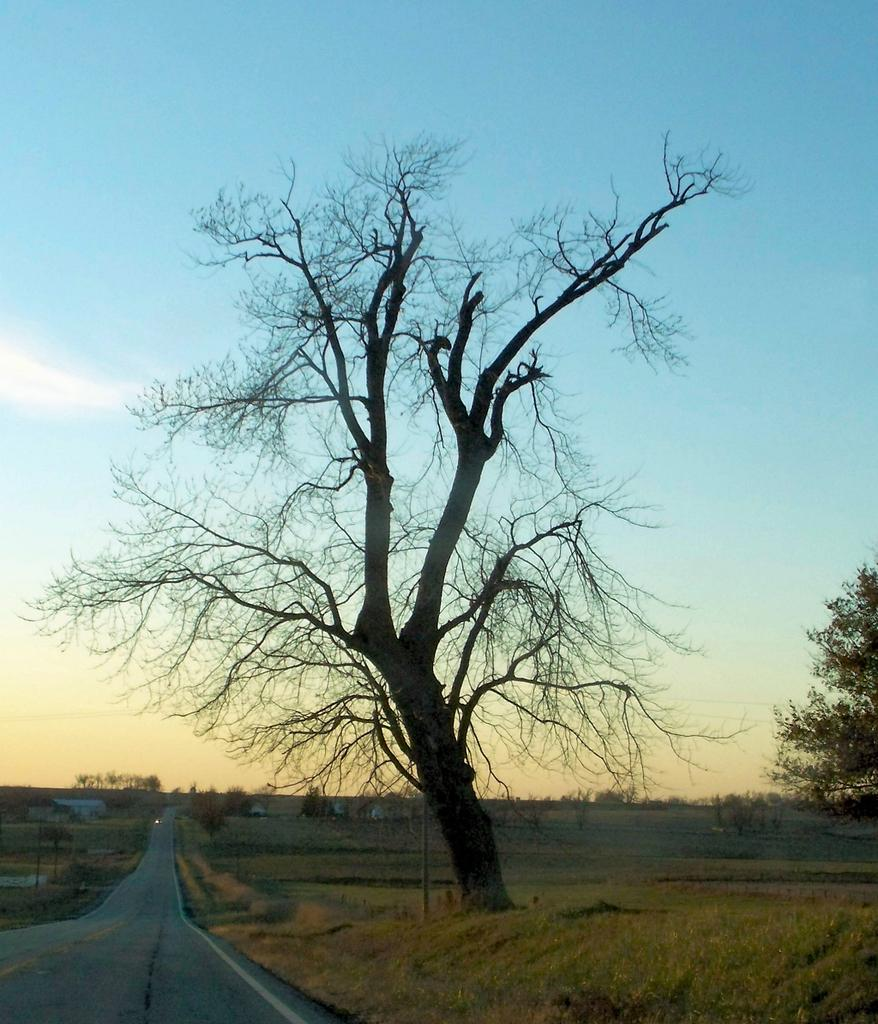What type of vegetation can be seen in the image? There are trees in the image. What type of structures are visible in the image? There are houses in the image. What are the poles in the image used for? The purpose of the poles in the image is not specified, but they could be for various purposes such as streetlights or utility lines. What is visible at the top of the image? The sky is visible at the top of the image. What is present at the bottom of the image? There is a road at the bottom of the image. What type of ground cover can be seen in the image? There is grass in the image. What type of berry is growing on the roof of the house in the image? There is no berry growing on the roof of the house in the image; there is no mention of a roof or berries in the provided facts. What color is the dress worn by the person in the image? There is no person or dress present in the image. 